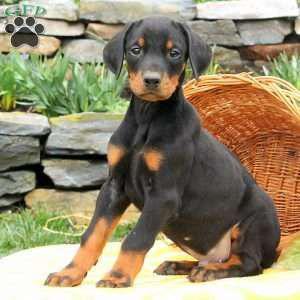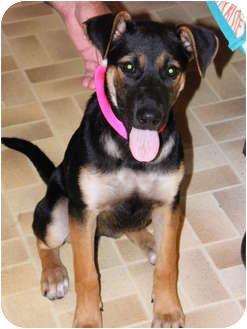The first image is the image on the left, the second image is the image on the right. Assess this claim about the two images: "One dog is sitting and isn't wearing a dog collar.". Correct or not? Answer yes or no. Yes. The first image is the image on the left, the second image is the image on the right. Evaluate the accuracy of this statement regarding the images: "At least one image features an adult doberman with erect pointy ears in an upright sitting position.". Is it true? Answer yes or no. No. 